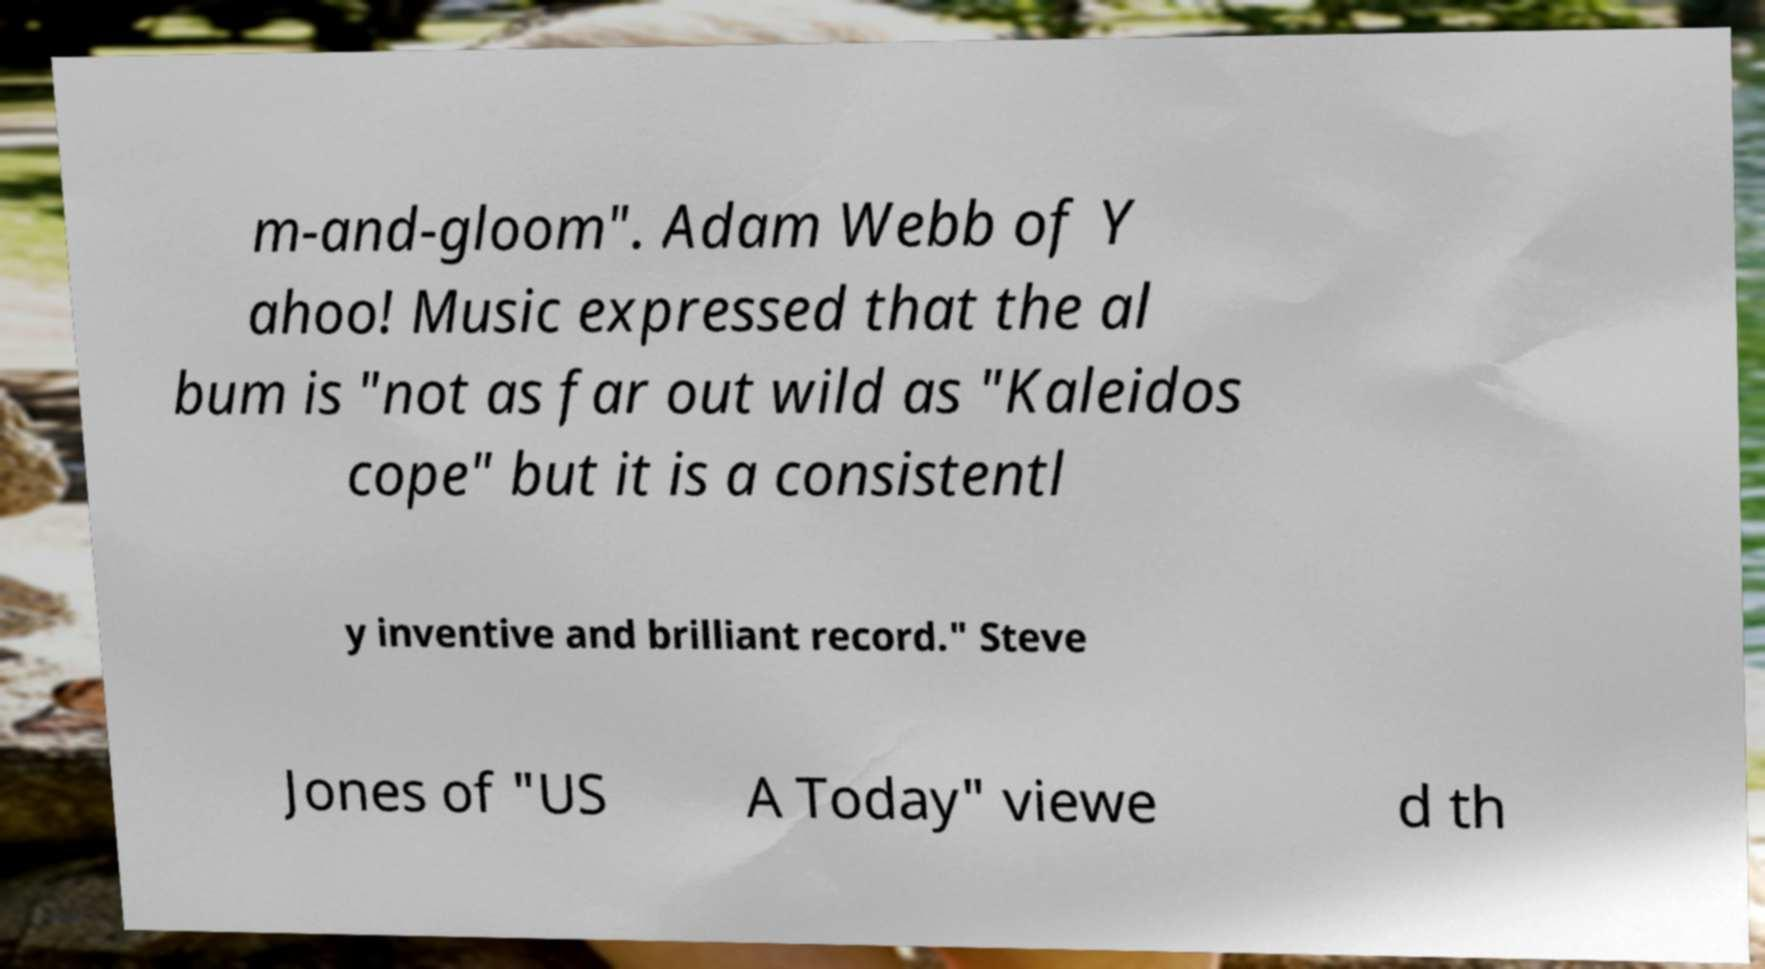Could you assist in decoding the text presented in this image and type it out clearly? m-and-gloom". Adam Webb of Y ahoo! Music expressed that the al bum is "not as far out wild as "Kaleidos cope" but it is a consistentl y inventive and brilliant record." Steve Jones of "US A Today" viewe d th 